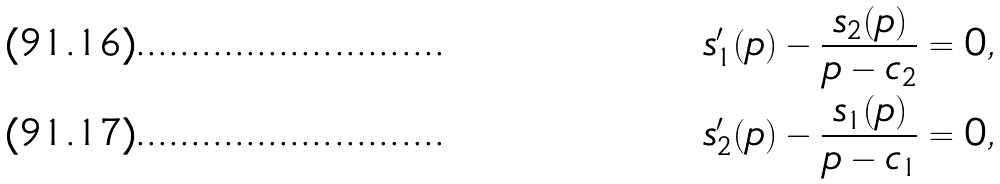Convert formula to latex. <formula><loc_0><loc_0><loc_500><loc_500>s _ { 1 } ^ { \prime } ( p ) - \frac { s _ { 2 } ( p ) } { p - c _ { 2 } } & = 0 , \\ s _ { 2 } ^ { \prime } ( p ) - \frac { s _ { 1 } ( p ) } { p - c _ { 1 } } & = 0 ,</formula> 